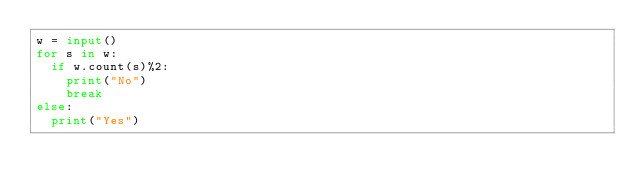Convert code to text. <code><loc_0><loc_0><loc_500><loc_500><_Python_>w = input()
for s in w:
  if w.count(s)%2:
    print("No")
    break
else:
  print("Yes")</code> 